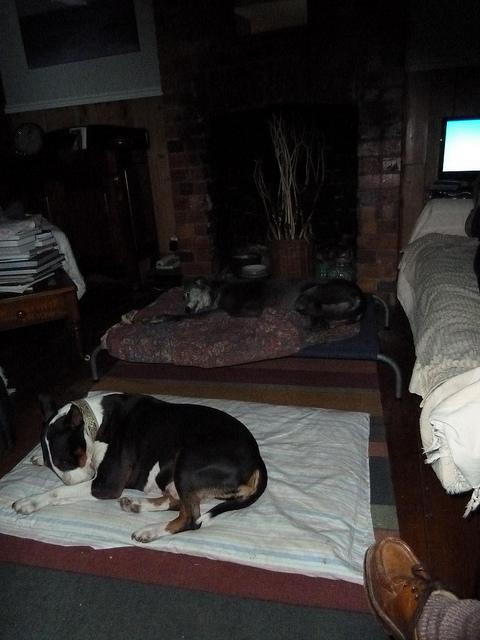What can be built along the back wall? Please explain your reasoning. fire. There is a fireplace on the back wall and a fire can be built here. 